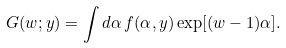<formula> <loc_0><loc_0><loc_500><loc_500>G ( w ; y ) = \int d \alpha \, f ( \alpha , y ) \, { \exp [ ( w - 1 ) \alpha ] } .</formula> 